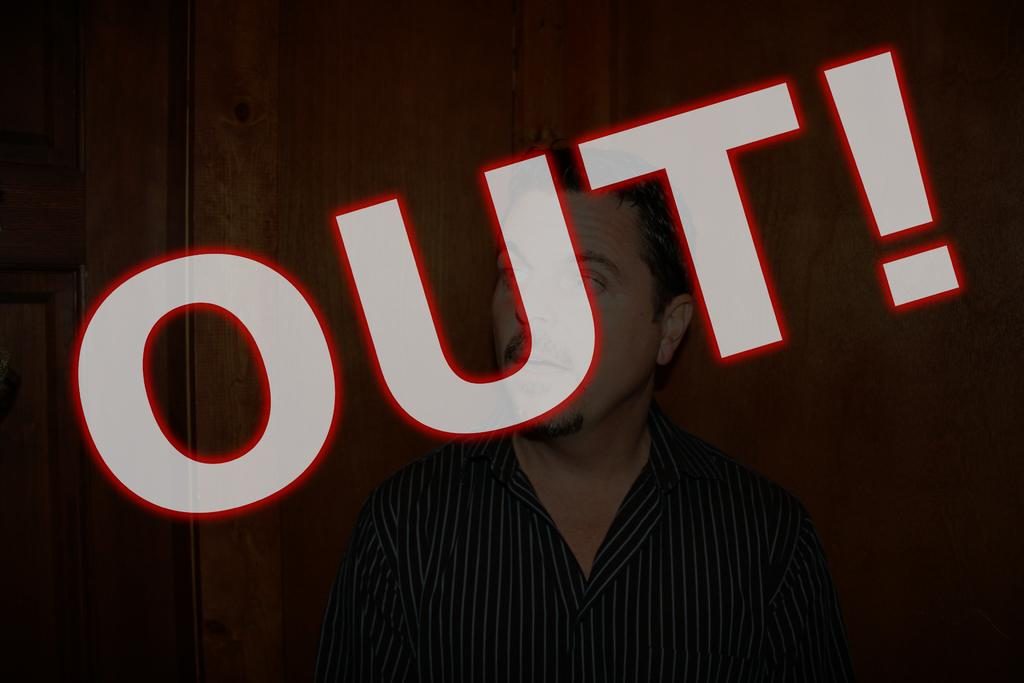Who is the main subject in the image? There is a man in the center of the image. What is located in the center of the image besides the man? There is some text in the center of the image. What can be seen in the background of the image? There is a wall in the background of the image. Where is the door located in the image? There is a door on the left side of the image. How many boys are playing on the coast in the image? There are no boys or coast present in the image. What type of flag is visible in the image? There is no flag present in the image. 